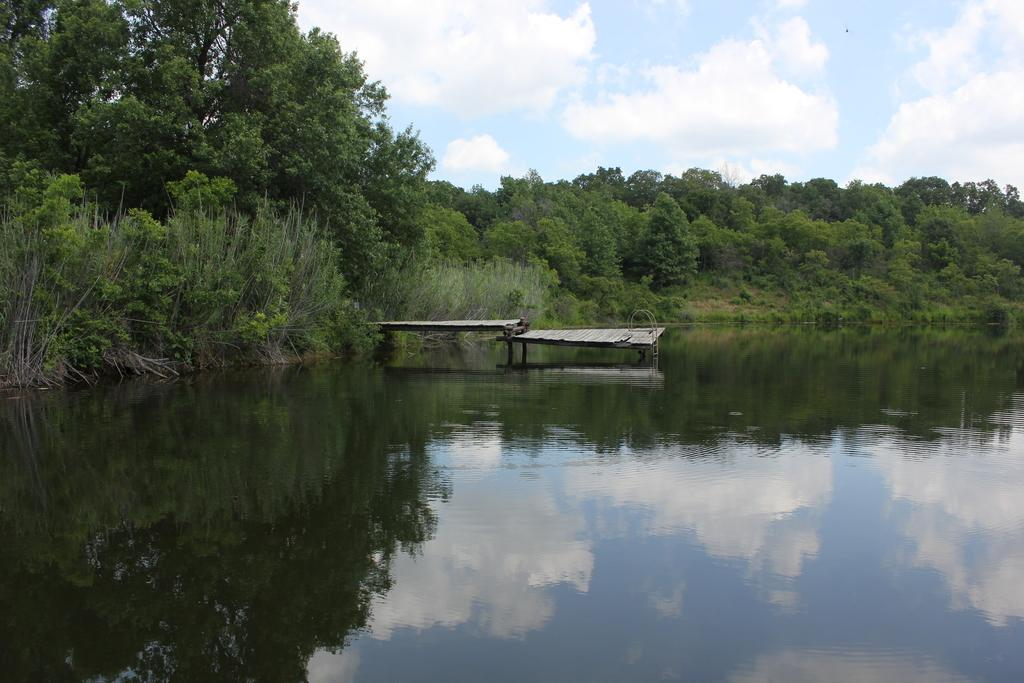What natural element can be seen in the image? Water is visible in the image. What type of structure is present in the image? There is a bridge in the image. What type of vegetation is visible in the image? There are trees in the image. What is visible in the sky in the image? The sky is visible in the image, and clouds are present in it. How many friends are visible in the image? There is no reference to friends in the image; it features water, a bridge, trees, and a sky with clouds. What type of badge is being worn by the trees in the image? There is no badge present in the image, as it features natural elements and a bridge. 